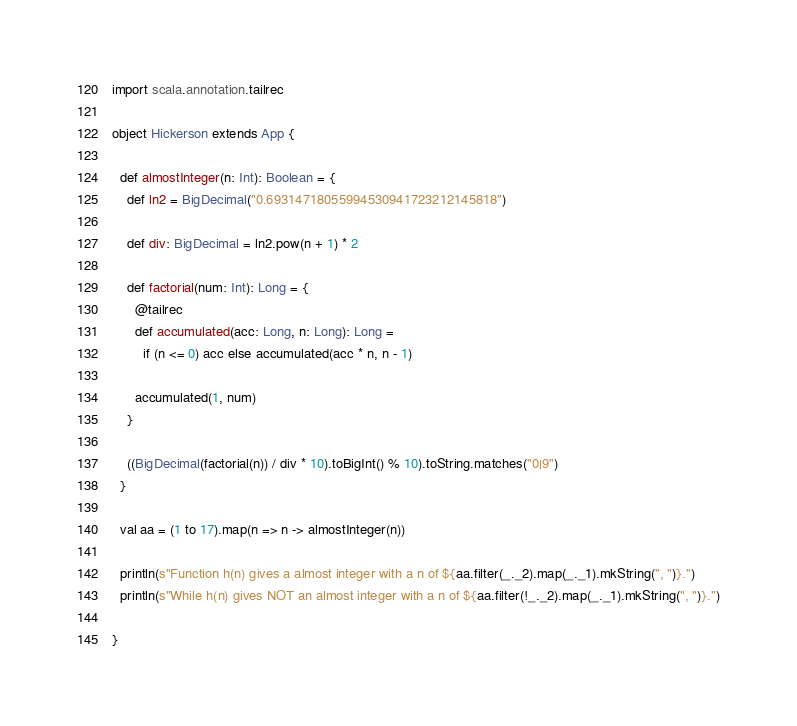<code> <loc_0><loc_0><loc_500><loc_500><_Scala_>import scala.annotation.tailrec

object Hickerson extends App {

  def almostInteger(n: Int): Boolean = {
    def ln2 = BigDecimal("0.69314718055994530941723212145818")

    def div: BigDecimal = ln2.pow(n + 1) * 2

    def factorial(num: Int): Long = {
      @tailrec
      def accumulated(acc: Long, n: Long): Long =
        if (n <= 0) acc else accumulated(acc * n, n - 1)

      accumulated(1, num)
    }

    ((BigDecimal(factorial(n)) / div * 10).toBigInt() % 10).toString.matches("0|9")
  }

  val aa = (1 to 17).map(n => n -> almostInteger(n))

  println(s"Function h(n) gives a almost integer with a n of ${aa.filter(_._2).map(_._1).mkString(", ")}.")
  println(s"While h(n) gives NOT an almost integer with a n of ${aa.filter(!_._2).map(_._1).mkString(", ")}.")

}
</code> 